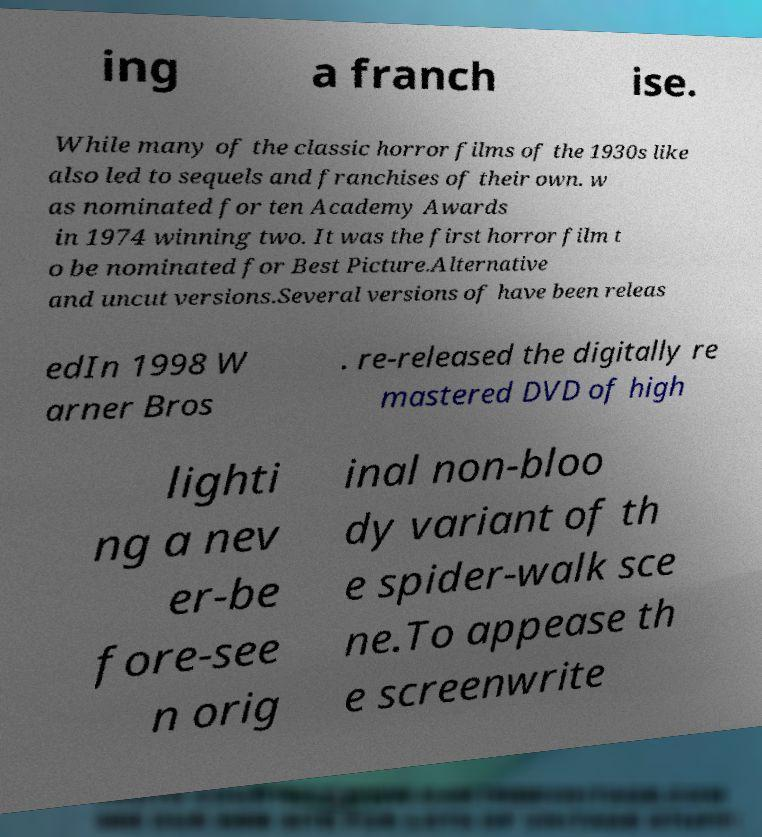Could you extract and type out the text from this image? ing a franch ise. While many of the classic horror films of the 1930s like also led to sequels and franchises of their own. w as nominated for ten Academy Awards in 1974 winning two. It was the first horror film t o be nominated for Best Picture.Alternative and uncut versions.Several versions of have been releas edIn 1998 W arner Bros . re-released the digitally re mastered DVD of high lighti ng a nev er-be fore-see n orig inal non-bloo dy variant of th e spider-walk sce ne.To appease th e screenwrite 